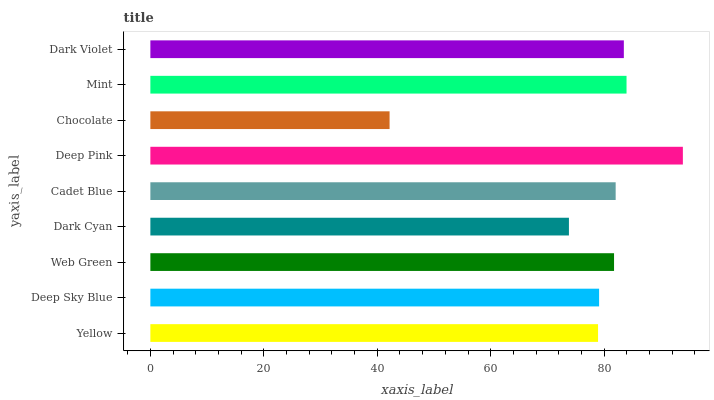Is Chocolate the minimum?
Answer yes or no. Yes. Is Deep Pink the maximum?
Answer yes or no. Yes. Is Deep Sky Blue the minimum?
Answer yes or no. No. Is Deep Sky Blue the maximum?
Answer yes or no. No. Is Deep Sky Blue greater than Yellow?
Answer yes or no. Yes. Is Yellow less than Deep Sky Blue?
Answer yes or no. Yes. Is Yellow greater than Deep Sky Blue?
Answer yes or no. No. Is Deep Sky Blue less than Yellow?
Answer yes or no. No. Is Web Green the high median?
Answer yes or no. Yes. Is Web Green the low median?
Answer yes or no. Yes. Is Chocolate the high median?
Answer yes or no. No. Is Chocolate the low median?
Answer yes or no. No. 